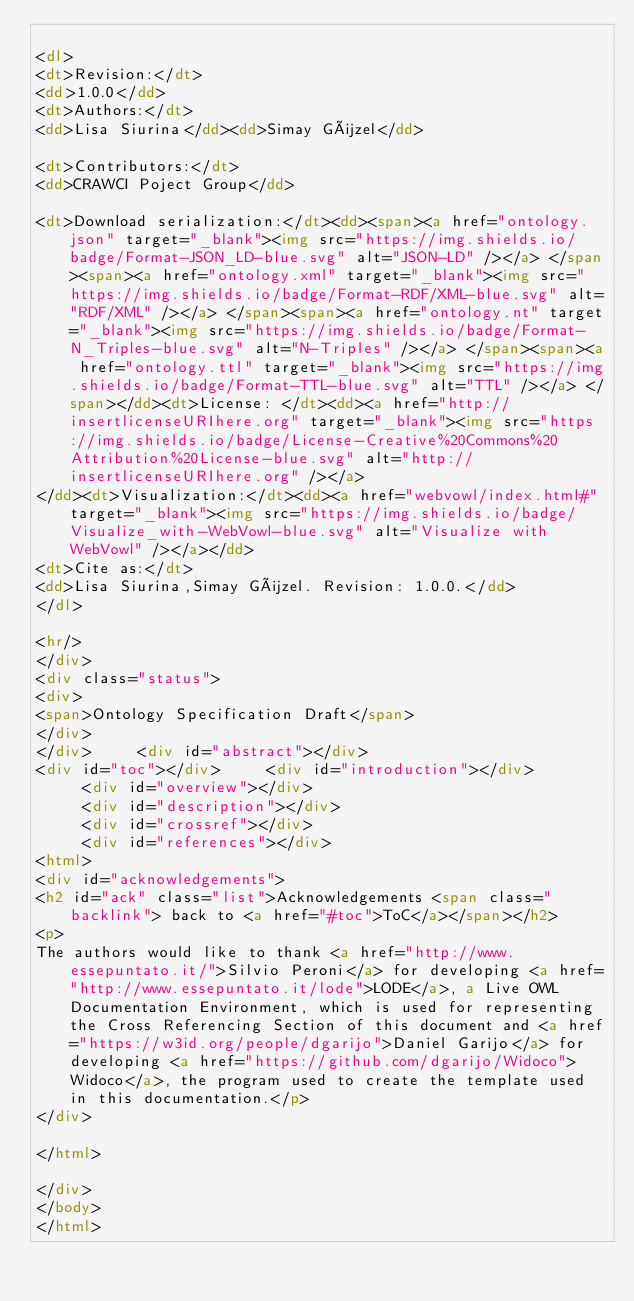<code> <loc_0><loc_0><loc_500><loc_500><_HTML_>
<dl>
<dt>Revision:</dt>
<dd>1.0.0</dd>
<dt>Authors:</dt>
<dd>Lisa Siurina</dd><dd>Simay Güzel</dd>

<dt>Contributors:</dt>
<dd>CRAWCI Poject Group</dd>

<dt>Download serialization:</dt><dd><span><a href="ontology.json" target="_blank"><img src="https://img.shields.io/badge/Format-JSON_LD-blue.svg" alt="JSON-LD" /></a> </span><span><a href="ontology.xml" target="_blank"><img src="https://img.shields.io/badge/Format-RDF/XML-blue.svg" alt="RDF/XML" /></a> </span><span><a href="ontology.nt" target="_blank"><img src="https://img.shields.io/badge/Format-N_Triples-blue.svg" alt="N-Triples" /></a> </span><span><a href="ontology.ttl" target="_blank"><img src="https://img.shields.io/badge/Format-TTL-blue.svg" alt="TTL" /></a> </span></dd><dt>License: </dt><dd><a href="http://insertlicenseURIhere.org" target="_blank"><img src="https://img.shields.io/badge/License-Creative%20Commons%20Attribution%20License-blue.svg" alt="http://insertlicenseURIhere.org" /></a>
</dd><dt>Visualization:</dt><dd><a href="webvowl/index.html#" target="_blank"><img src="https://img.shields.io/badge/Visualize_with-WebVowl-blue.svg" alt="Visualize with WebVowl" /></a></dd>
<dt>Cite as:</dt>
<dd>Lisa Siurina,Simay Güzel. Revision: 1.0.0.</dd>
</dl>

<hr/>
</div>
<div class="status">
<div>
<span>Ontology Specification Draft</span>
</div>
</div>     <div id="abstract"></div>
<div id="toc"></div>     <div id="introduction"></div>
     <div id="overview"></div>
     <div id="description"></div>
     <div id="crossref"></div>
     <div id="references"></div>
<html>
<div id="acknowledgements">
<h2 id="ack" class="list">Acknowledgements <span class="backlink"> back to <a href="#toc">ToC</a></span></h2>
<p>
The authors would like to thank <a href="http://www.essepuntato.it/">Silvio Peroni</a> for developing <a href="http://www.essepuntato.it/lode">LODE</a>, a Live OWL Documentation Environment, which is used for representing the Cross Referencing Section of this document and <a href="https://w3id.org/people/dgarijo">Daniel Garijo</a> for developing <a href="https://github.com/dgarijo/Widoco">Widoco</a>, the program used to create the template used in this documentation.</p>
</div>

</html>

</div>
</body>
</html></code> 